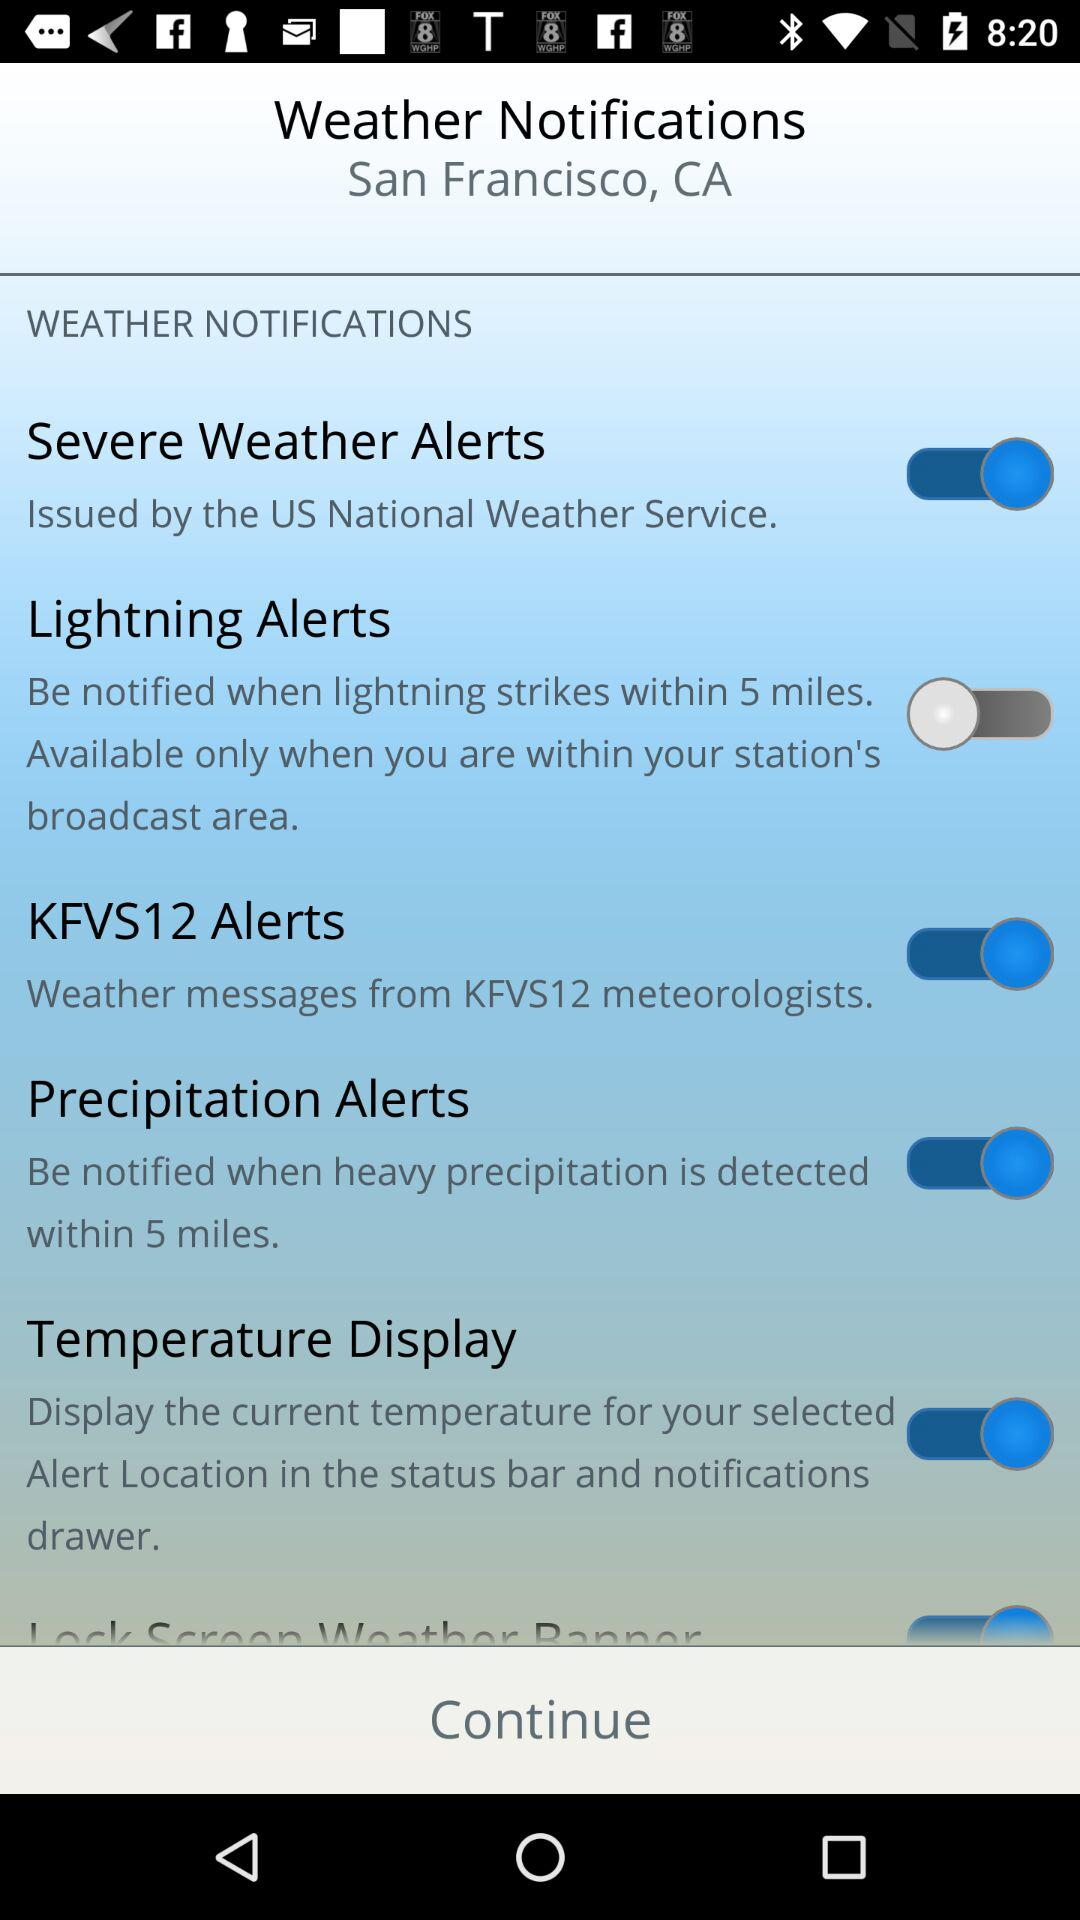What is the status of "Lightning Alerts"? The status is "off". 